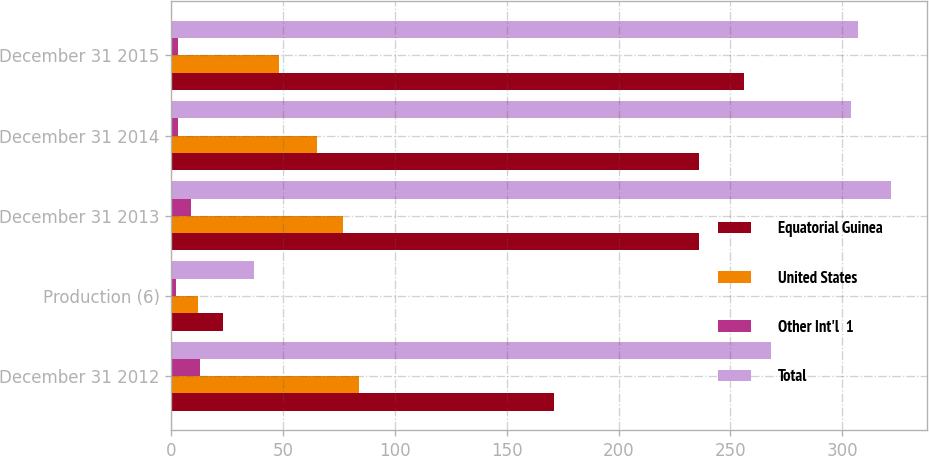Convert chart. <chart><loc_0><loc_0><loc_500><loc_500><stacked_bar_chart><ecel><fcel>December 31 2012<fcel>Production (6)<fcel>December 31 2013<fcel>December 31 2014<fcel>December 31 2015<nl><fcel>Equatorial Guinea<fcel>171<fcel>23<fcel>236<fcel>236<fcel>256<nl><fcel>United States<fcel>84<fcel>12<fcel>77<fcel>65<fcel>48<nl><fcel>Other Int'l  1<fcel>13<fcel>2<fcel>9<fcel>3<fcel>3<nl><fcel>Total<fcel>268<fcel>37<fcel>322<fcel>304<fcel>307<nl></chart> 